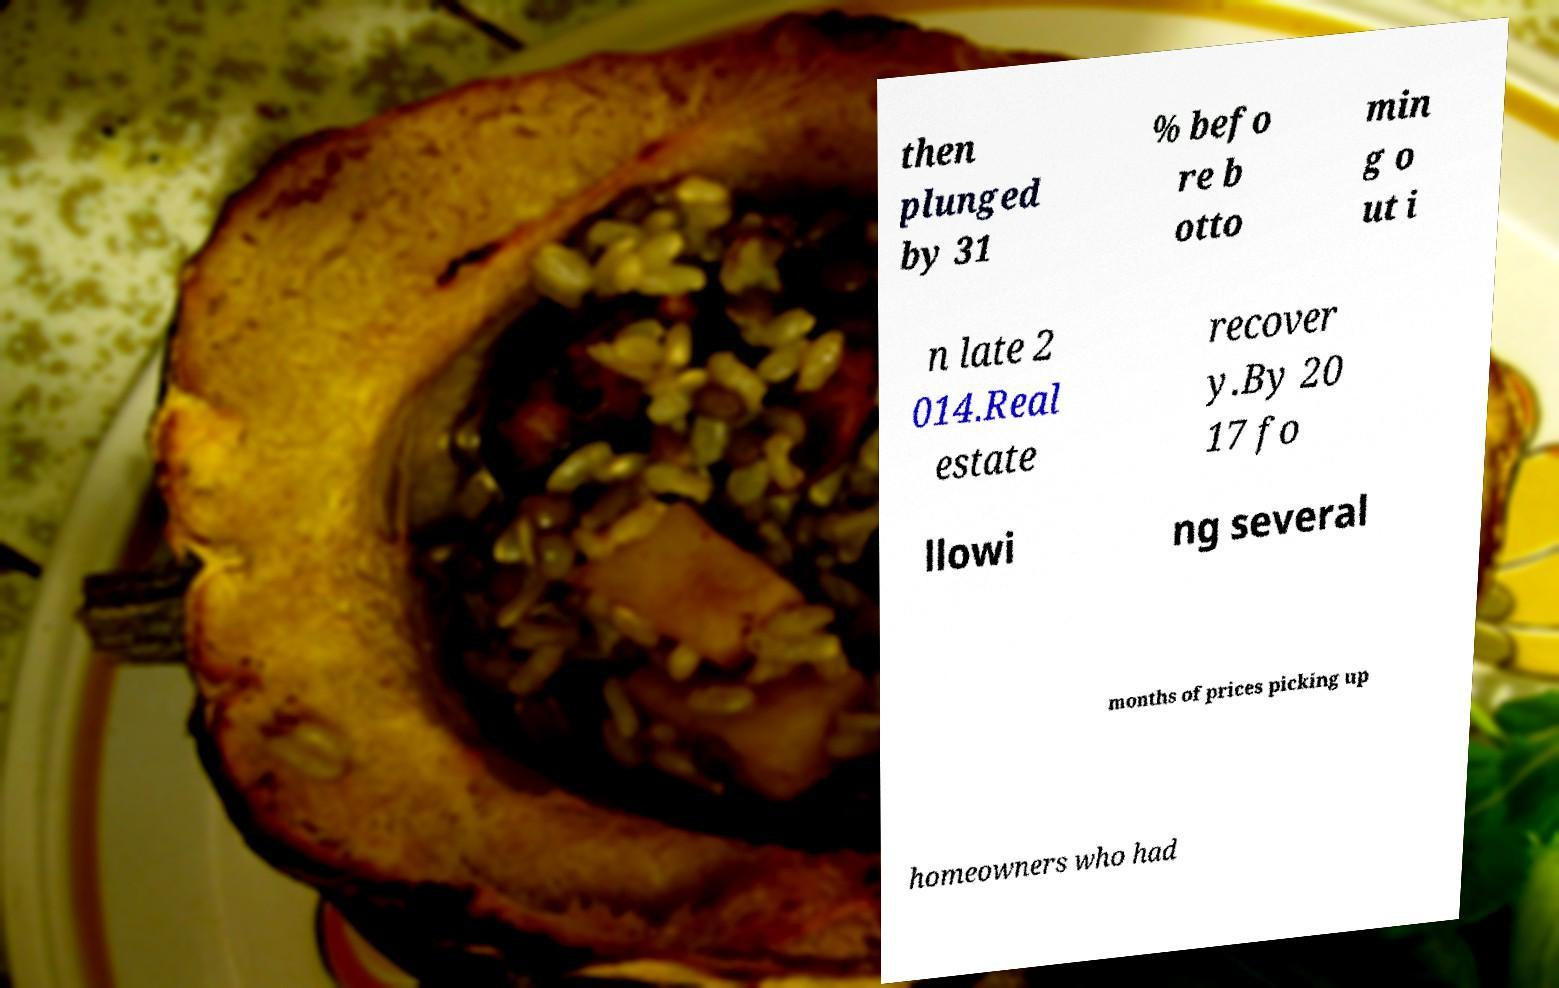I need the written content from this picture converted into text. Can you do that? then plunged by 31 % befo re b otto min g o ut i n late 2 014.Real estate recover y.By 20 17 fo llowi ng several months of prices picking up homeowners who had 